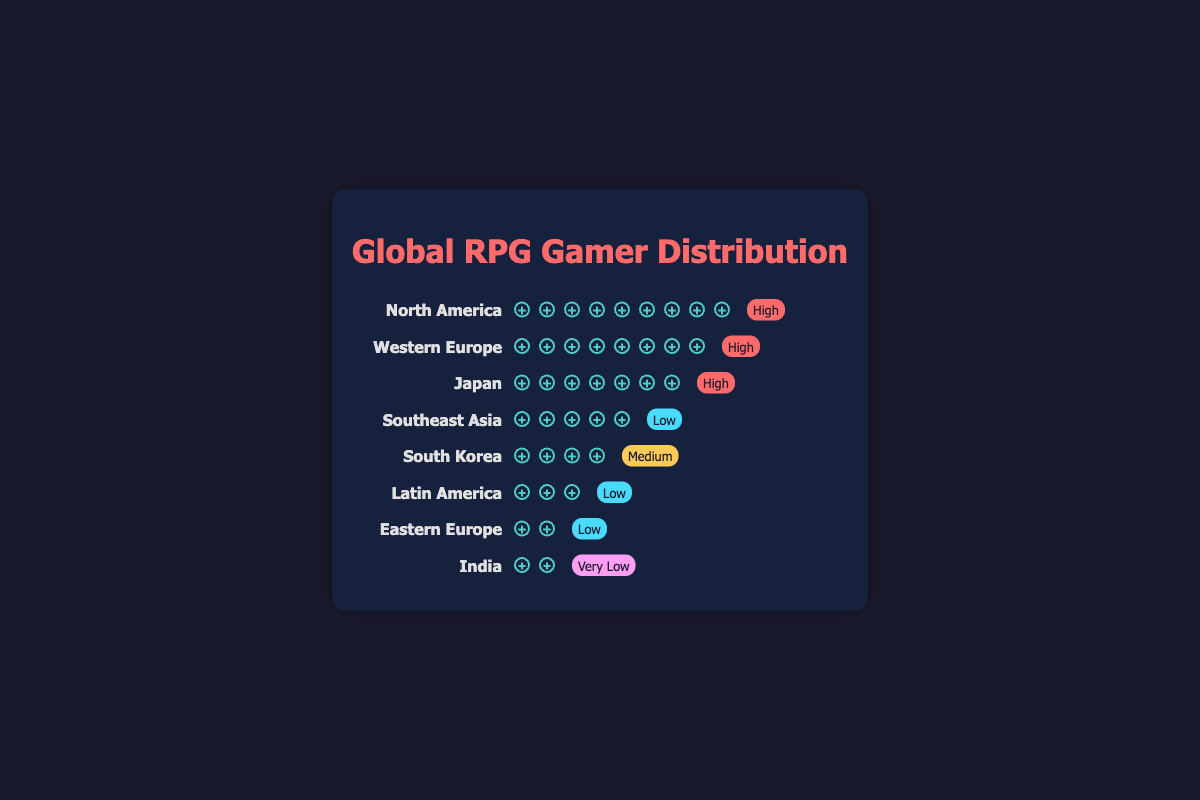What region has the highest number of RPG gamers? By visually examining the icons, you can see North America has the longest row of gamer icons, indicating the highest number of RPG gamers.
Answer: North America How many RPG gamers are there in Japan? Count the number of gamer icons in the row labeled Japan. There are 35 icons.
Answer: 35 Which region has the lowest market saturation and how many RPG gamers are there? India is labeled with a "Very Low" saturation, and by counting its gamer icons, you see it has 8 gamers.
Answer: India, 8 How many markets have a 'High' saturation level? North America, Western Europe, and Japan have "High" saturation, so there are 3 regions.
Answer: 3 Compare the number of RPG gamers in Southeast Asia and South Korea. Which region has more? Southeast Asia has 25 gamer icons, while South Korea has 20. Thus, Southeast Asia has more gamers.
Answer: Southeast Asia What is the combined number of RPG gamers in Eastern Europe and Latin America? Add the RPG gamers for Eastern Europe (10) and Latin America (15): 10 + 15 = 25.
Answer: 25 Which two regions together have an equal number of RPG gamers to North America? North America has 45 gamers. Adding Western Europe (40) and India (8) does not equal 45. Adding Southeast Asia (25) and South Korea (20) equals 45. Thus, Southeast Asia and South Korea.
Answer: Southeast Asia and South Korea Which region has a Medium level of market saturation and how does its number of RPG gamers compare to Western Europe? South Korea has "Medium" saturation and 20 gamers, while Western Europe has "High" saturation and 40 gamers. South Korea has fewer gamers.
Answer: South Korea has fewer gamers than Western Europe Order the regions by the number of RPG gamers from highest to lowest. By counting the gamer icons for each region and arranging them, you get: North America (45), Western Europe (40), Japan (35), Southeast Asia (25), South Korea (20), Latin America (15), Eastern Europe (10), India (8).
Answer: North America, Western Europe, Japan, Southeast Asia, South Korea, Latin America, Eastern Europe, India 